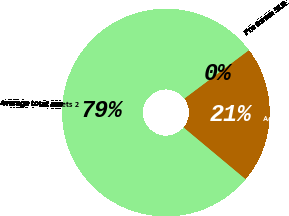Convert chart to OTSL. <chart><loc_0><loc_0><loc_500><loc_500><pie_chart><fcel>Average total assets 2<fcel>Adjustments 3 4<fcel>Pro forma SLR<nl><fcel>78.68%<fcel>21.31%<fcel>0.0%<nl></chart> 